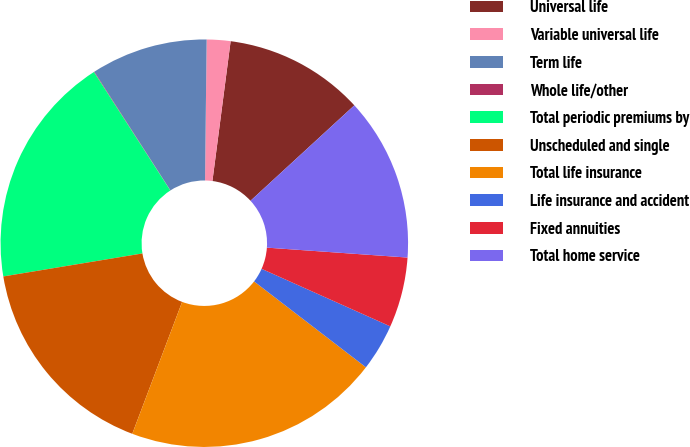Convert chart to OTSL. <chart><loc_0><loc_0><loc_500><loc_500><pie_chart><fcel>Universal life<fcel>Variable universal life<fcel>Term life<fcel>Whole life/other<fcel>Total periodic premiums by<fcel>Unscheduled and single<fcel>Total life insurance<fcel>Life insurance and accident<fcel>Fixed annuities<fcel>Total home service<nl><fcel>11.11%<fcel>1.88%<fcel>9.26%<fcel>0.04%<fcel>18.49%<fcel>16.64%<fcel>20.33%<fcel>3.73%<fcel>5.57%<fcel>12.95%<nl></chart> 